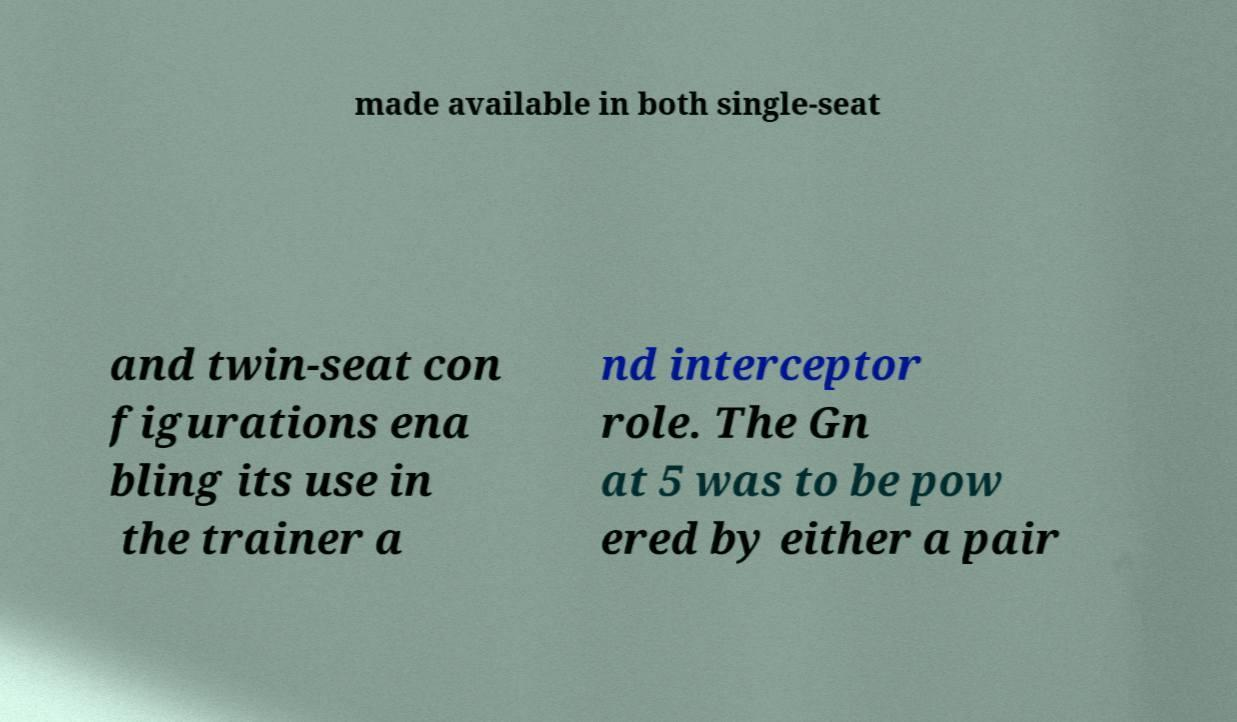What messages or text are displayed in this image? I need them in a readable, typed format. made available in both single-seat and twin-seat con figurations ena bling its use in the trainer a nd interceptor role. The Gn at 5 was to be pow ered by either a pair 